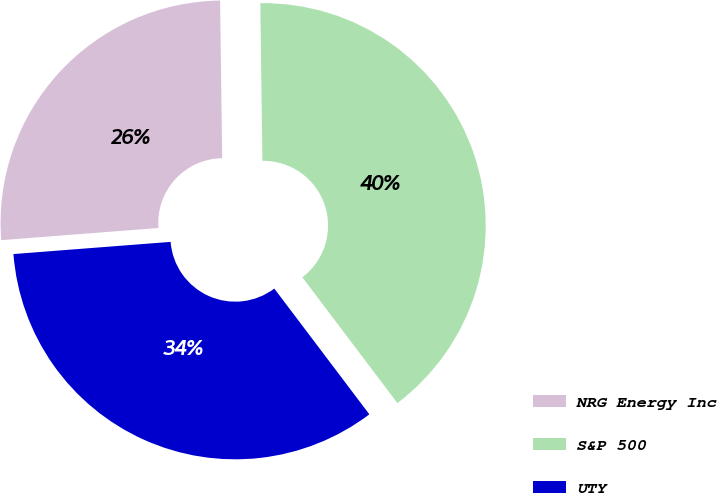Convert chart to OTSL. <chart><loc_0><loc_0><loc_500><loc_500><pie_chart><fcel>NRG Energy Inc<fcel>S&P 500<fcel>UTY<nl><fcel>26.02%<fcel>39.91%<fcel>34.07%<nl></chart> 